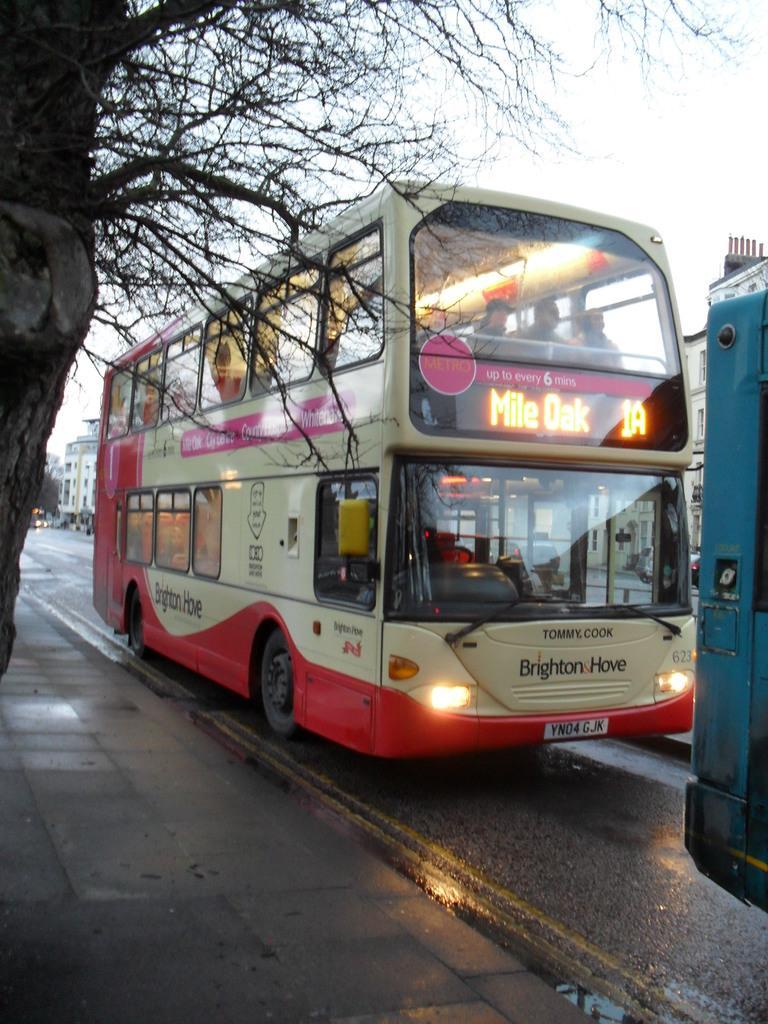Could you give a brief overview of what you see in this image? In this image I can see the vehicles on the road. To the left I can see the tree. To the right I can see many buildings, trees and the sky. 